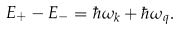<formula> <loc_0><loc_0><loc_500><loc_500>E _ { + } - E _ { - } = \hbar { \omega } _ { k } + \hbar { \omega } _ { q } .</formula> 